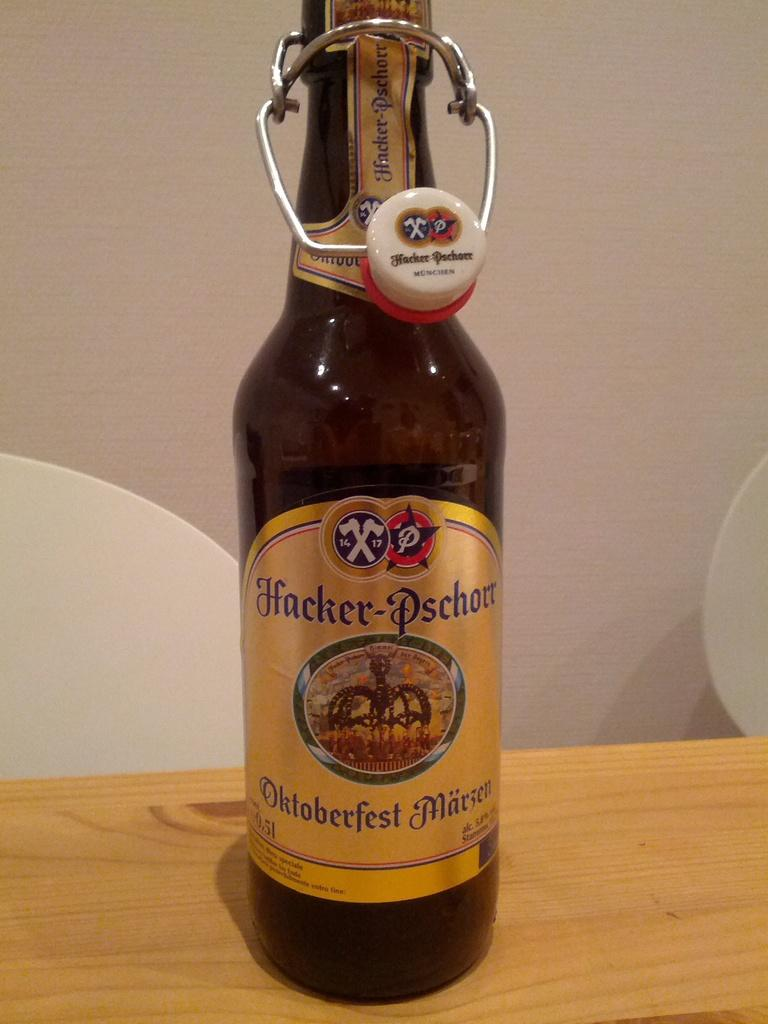Provide a one-sentence caption for the provided image. A bottle of Hacker-Pschorr Oktoberfest beer sits on a wooden table. 